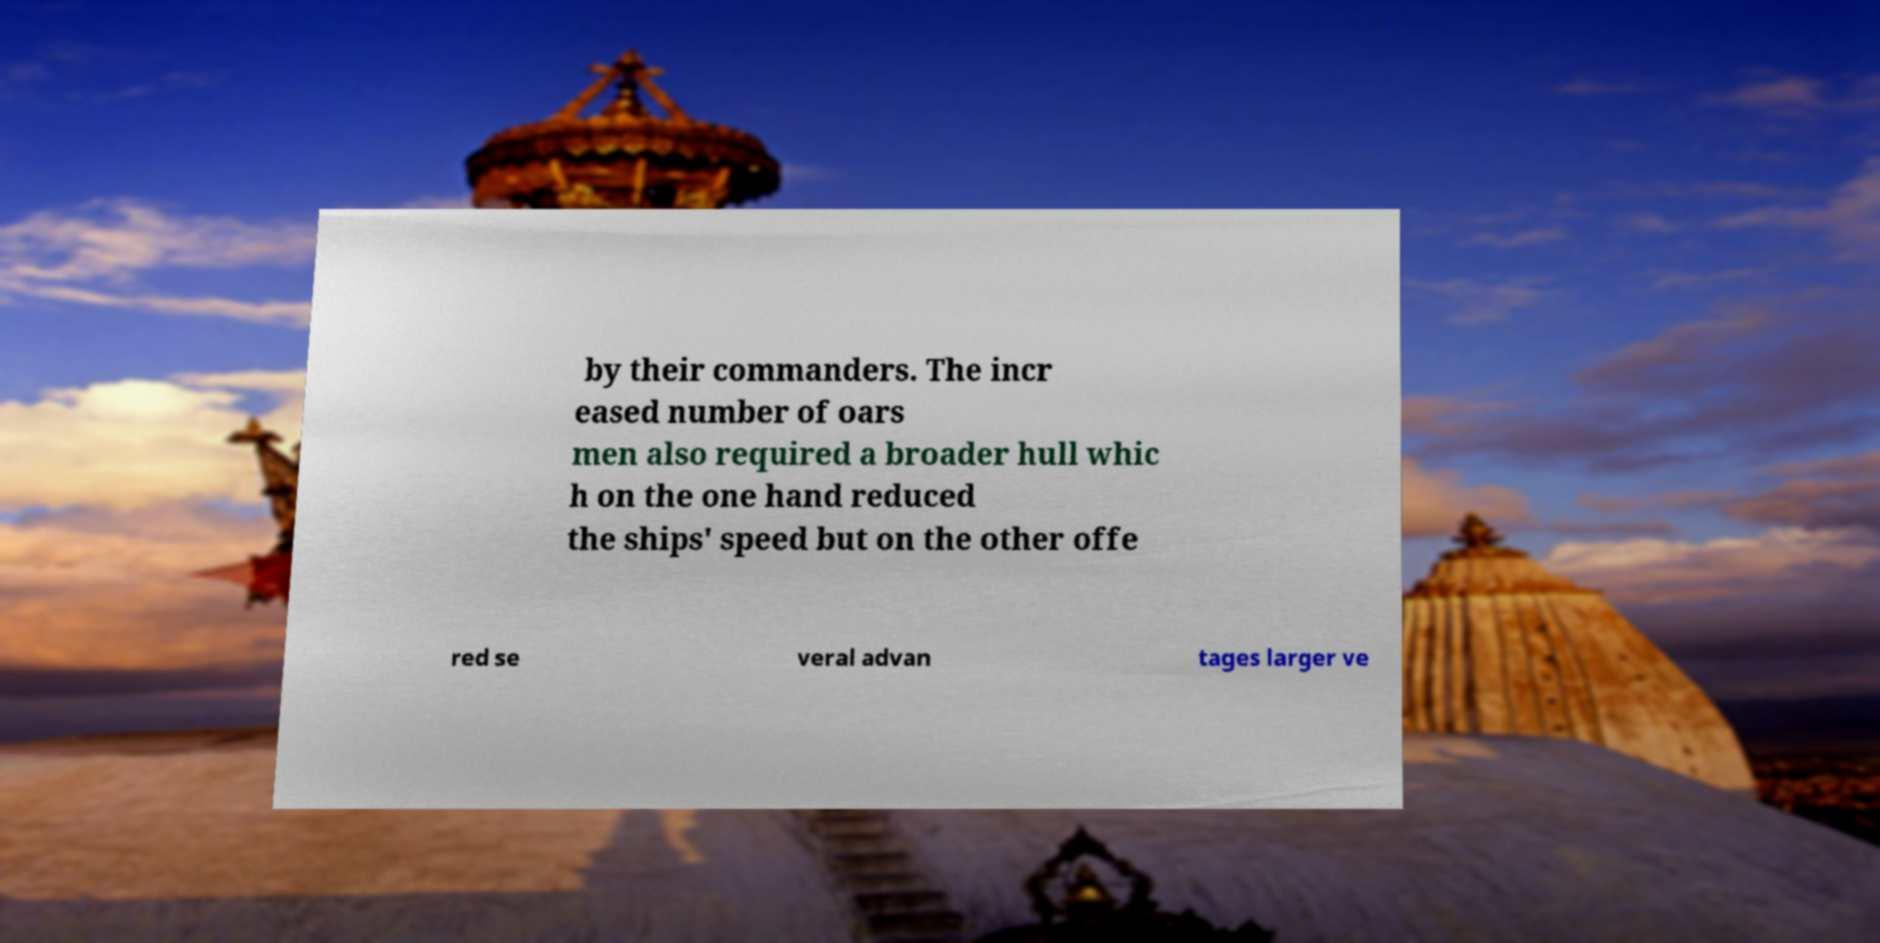Can you accurately transcribe the text from the provided image for me? by their commanders. The incr eased number of oars men also required a broader hull whic h on the one hand reduced the ships' speed but on the other offe red se veral advan tages larger ve 